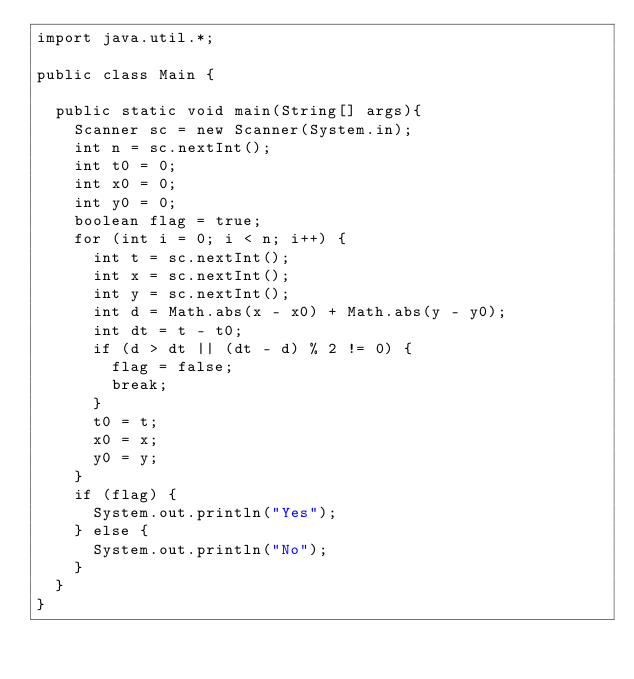<code> <loc_0><loc_0><loc_500><loc_500><_Java_>import java.util.*;

public class Main {

	public static void main(String[] args){
		Scanner sc = new Scanner(System.in);
		int n = sc.nextInt();
		int t0 = 0;
		int x0 = 0;
		int y0 = 0;
		boolean flag = true;
		for (int i = 0; i < n; i++) {
			int t = sc.nextInt();
			int x = sc.nextInt();
			int y = sc.nextInt();
			int d = Math.abs(x - x0) + Math.abs(y - y0);
			int dt = t - t0;
			if (d > dt || (dt - d) % 2 != 0) {
				flag = false;
				break;
			}
			t0 = t;
			x0 = x;
			y0 = y;
		}
		if (flag) {
			System.out.println("Yes");
		} else {
			System.out.println("No");
		}
	}
}
</code> 